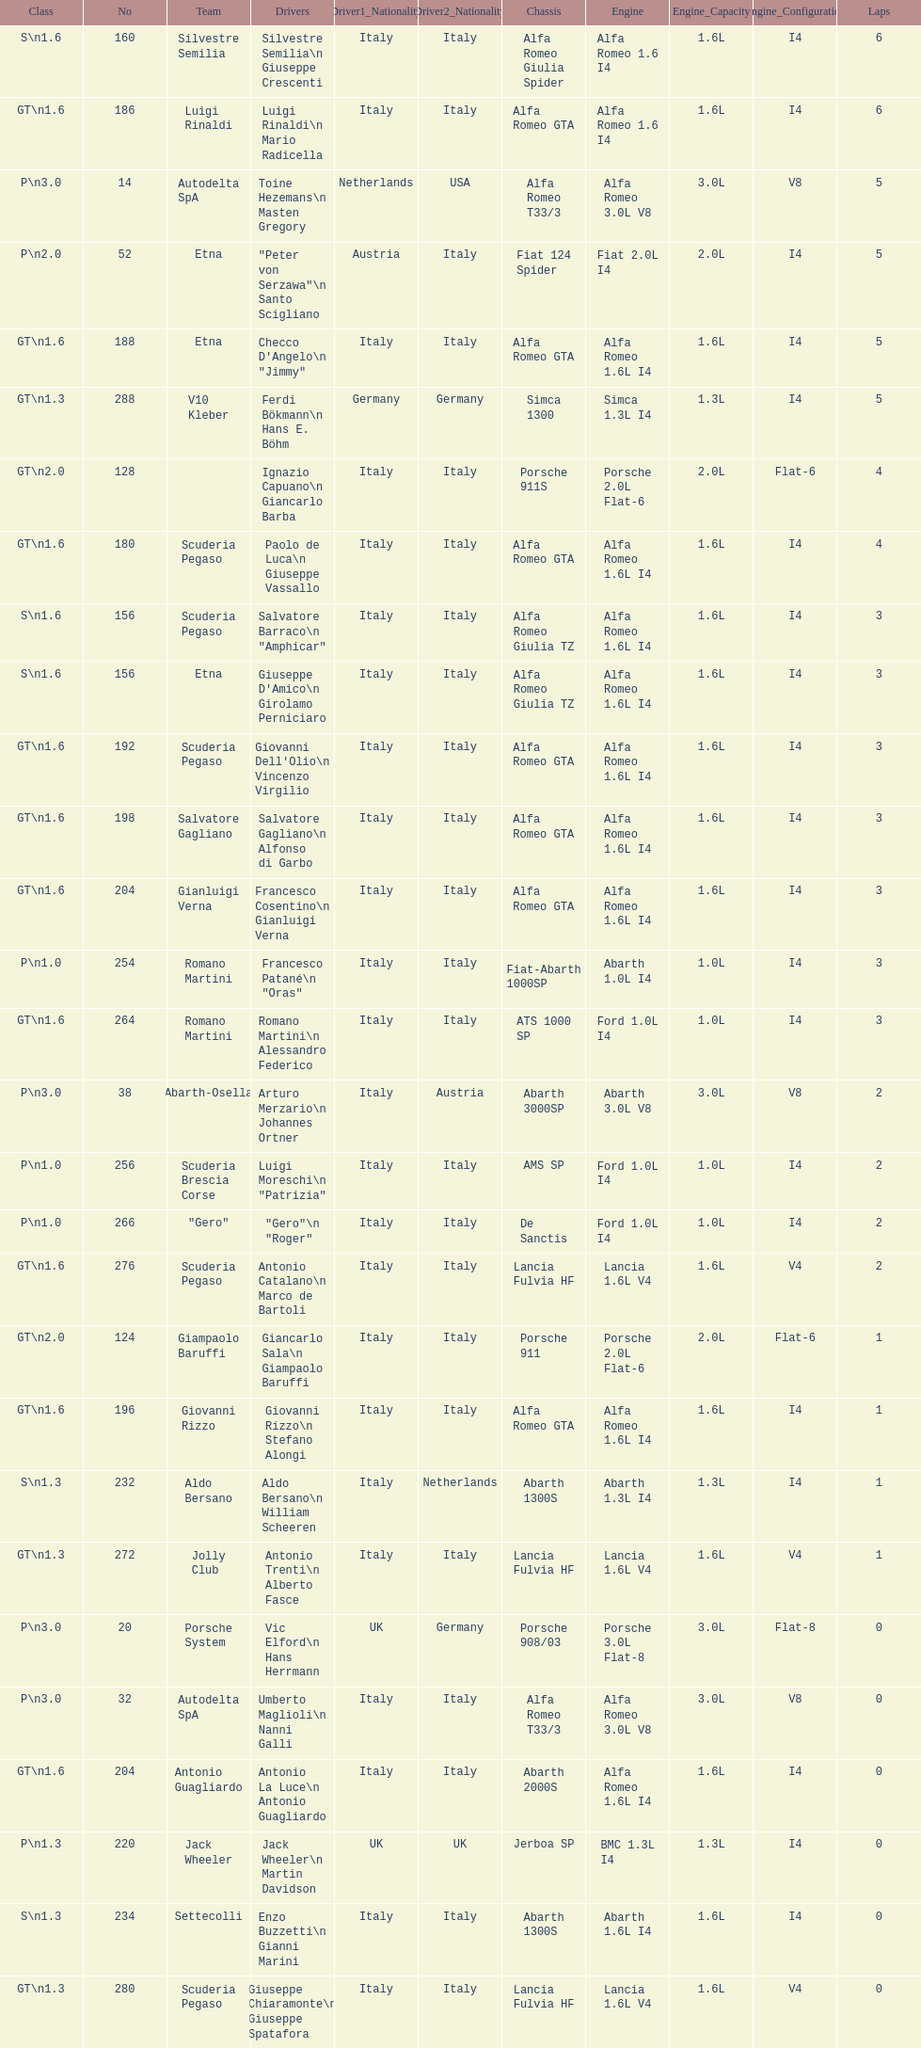His nickname is "jimmy," but what is his full name? Checco D'Angelo. 